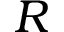<formula> <loc_0><loc_0><loc_500><loc_500>R</formula> 